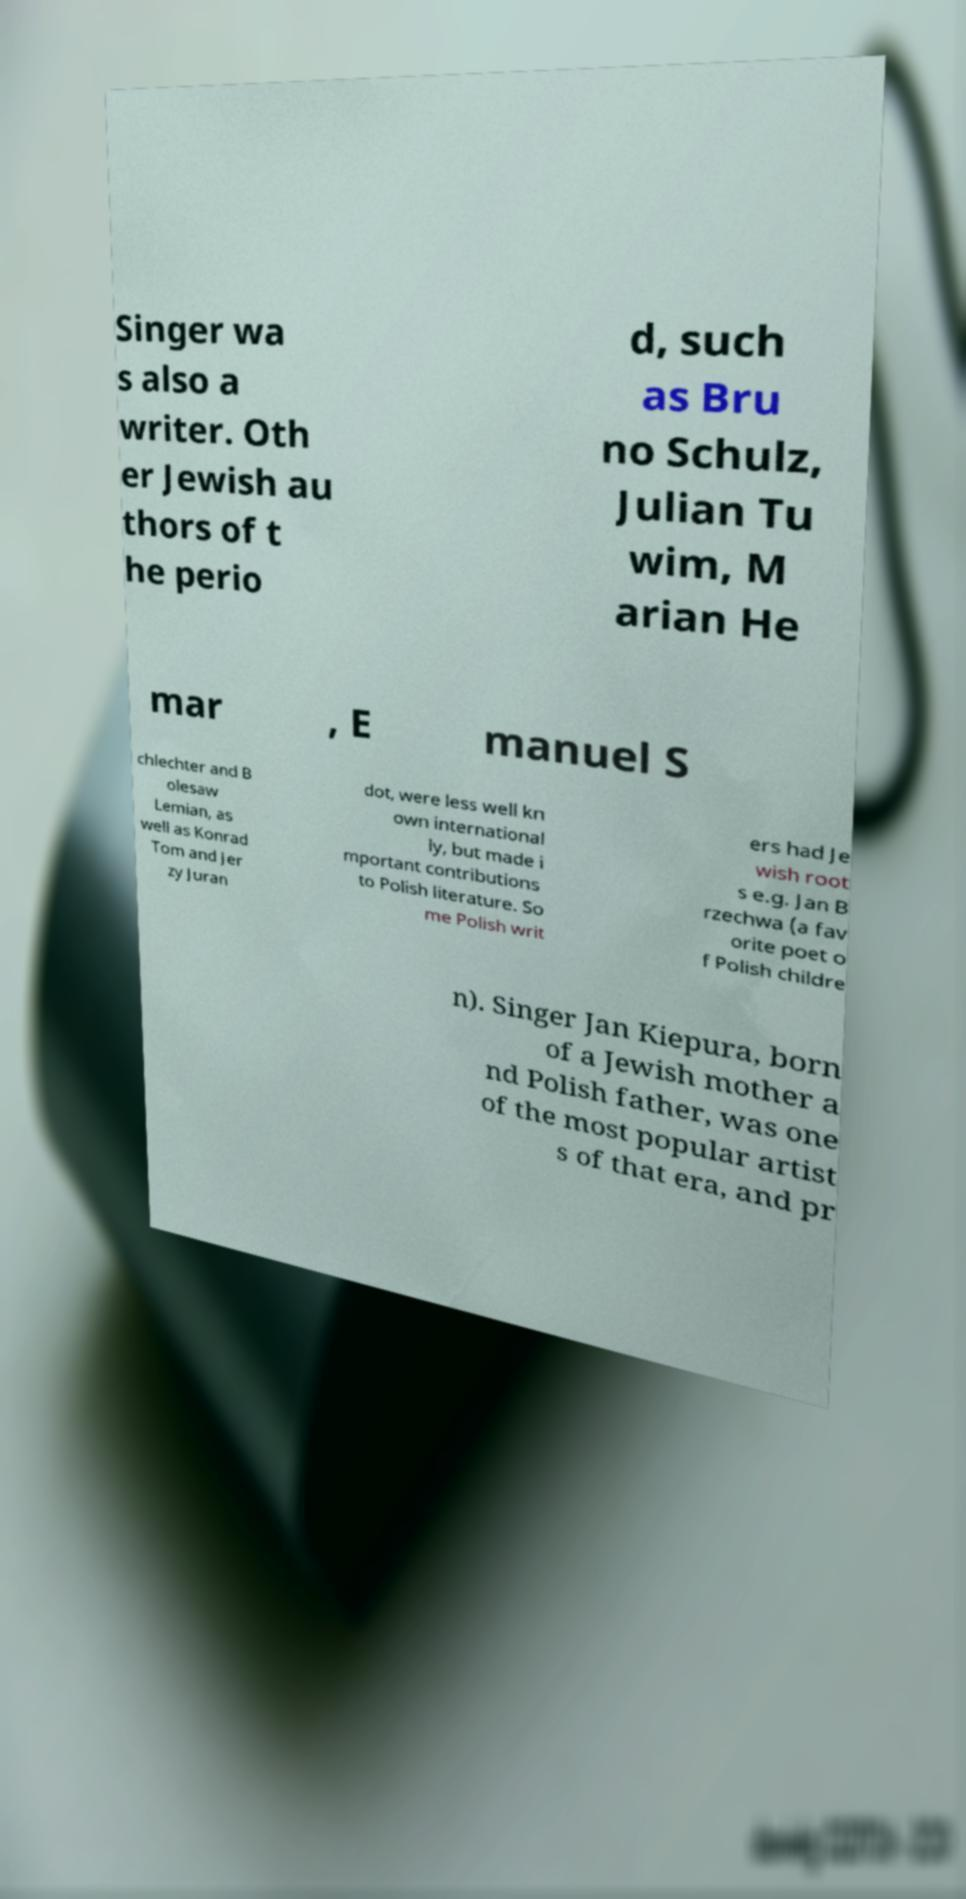Can you accurately transcribe the text from the provided image for me? Singer wa s also a writer. Oth er Jewish au thors of t he perio d, such as Bru no Schulz, Julian Tu wim, M arian He mar , E manuel S chlechter and B olesaw Lemian, as well as Konrad Tom and Jer zy Juran dot, were less well kn own international ly, but made i mportant contributions to Polish literature. So me Polish writ ers had Je wish root s e.g. Jan B rzechwa (a fav orite poet o f Polish childre n). Singer Jan Kiepura, born of a Jewish mother a nd Polish father, was one of the most popular artist s of that era, and pr 